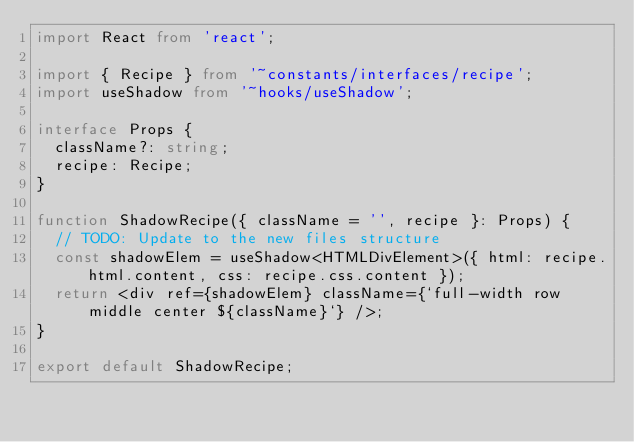<code> <loc_0><loc_0><loc_500><loc_500><_TypeScript_>import React from 'react';

import { Recipe } from '~constants/interfaces/recipe';
import useShadow from '~hooks/useShadow';

interface Props {
  className?: string;
  recipe: Recipe;
}

function ShadowRecipe({ className = '', recipe }: Props) {
  // TODO: Update to the new files structure
  const shadowElem = useShadow<HTMLDivElement>({ html: recipe.html.content, css: recipe.css.content });
  return <div ref={shadowElem} className={`full-width row middle center ${className}`} />;
}

export default ShadowRecipe;
</code> 